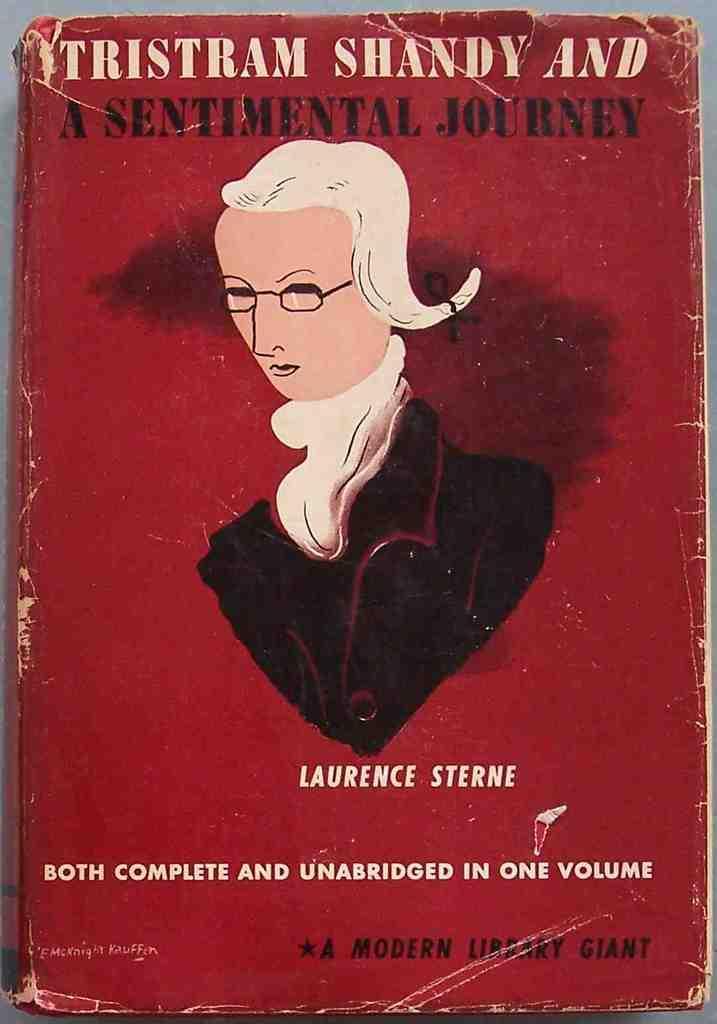Could you give a brief overview of what you see in this image? In this image we can see a cover page of a book, with some texts, and image in it. 